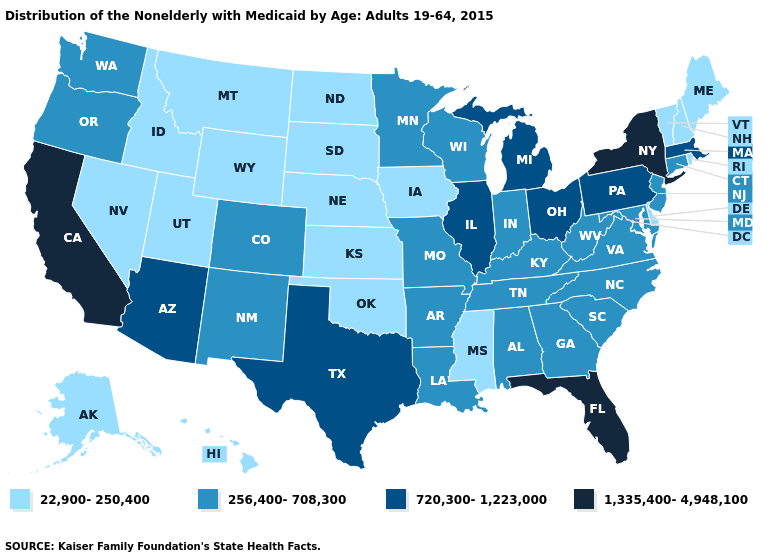Name the states that have a value in the range 256,400-708,300?
Keep it brief. Alabama, Arkansas, Colorado, Connecticut, Georgia, Indiana, Kentucky, Louisiana, Maryland, Minnesota, Missouri, New Jersey, New Mexico, North Carolina, Oregon, South Carolina, Tennessee, Virginia, Washington, West Virginia, Wisconsin. What is the value of New Jersey?
Write a very short answer. 256,400-708,300. Name the states that have a value in the range 256,400-708,300?
Quick response, please. Alabama, Arkansas, Colorado, Connecticut, Georgia, Indiana, Kentucky, Louisiana, Maryland, Minnesota, Missouri, New Jersey, New Mexico, North Carolina, Oregon, South Carolina, Tennessee, Virginia, Washington, West Virginia, Wisconsin. What is the value of Virginia?
Keep it brief. 256,400-708,300. How many symbols are there in the legend?
Be succinct. 4. What is the value of Utah?
Be succinct. 22,900-250,400. Name the states that have a value in the range 22,900-250,400?
Answer briefly. Alaska, Delaware, Hawaii, Idaho, Iowa, Kansas, Maine, Mississippi, Montana, Nebraska, Nevada, New Hampshire, North Dakota, Oklahoma, Rhode Island, South Dakota, Utah, Vermont, Wyoming. What is the value of Vermont?
Answer briefly. 22,900-250,400. Name the states that have a value in the range 1,335,400-4,948,100?
Keep it brief. California, Florida, New York. Name the states that have a value in the range 720,300-1,223,000?
Give a very brief answer. Arizona, Illinois, Massachusetts, Michigan, Ohio, Pennsylvania, Texas. What is the highest value in states that border Utah?
Write a very short answer. 720,300-1,223,000. Name the states that have a value in the range 22,900-250,400?
Give a very brief answer. Alaska, Delaware, Hawaii, Idaho, Iowa, Kansas, Maine, Mississippi, Montana, Nebraska, Nevada, New Hampshire, North Dakota, Oklahoma, Rhode Island, South Dakota, Utah, Vermont, Wyoming. Does Montana have the lowest value in the West?
Concise answer only. Yes. What is the highest value in the USA?
Keep it brief. 1,335,400-4,948,100. Does Nebraska have a higher value than Arkansas?
Answer briefly. No. 